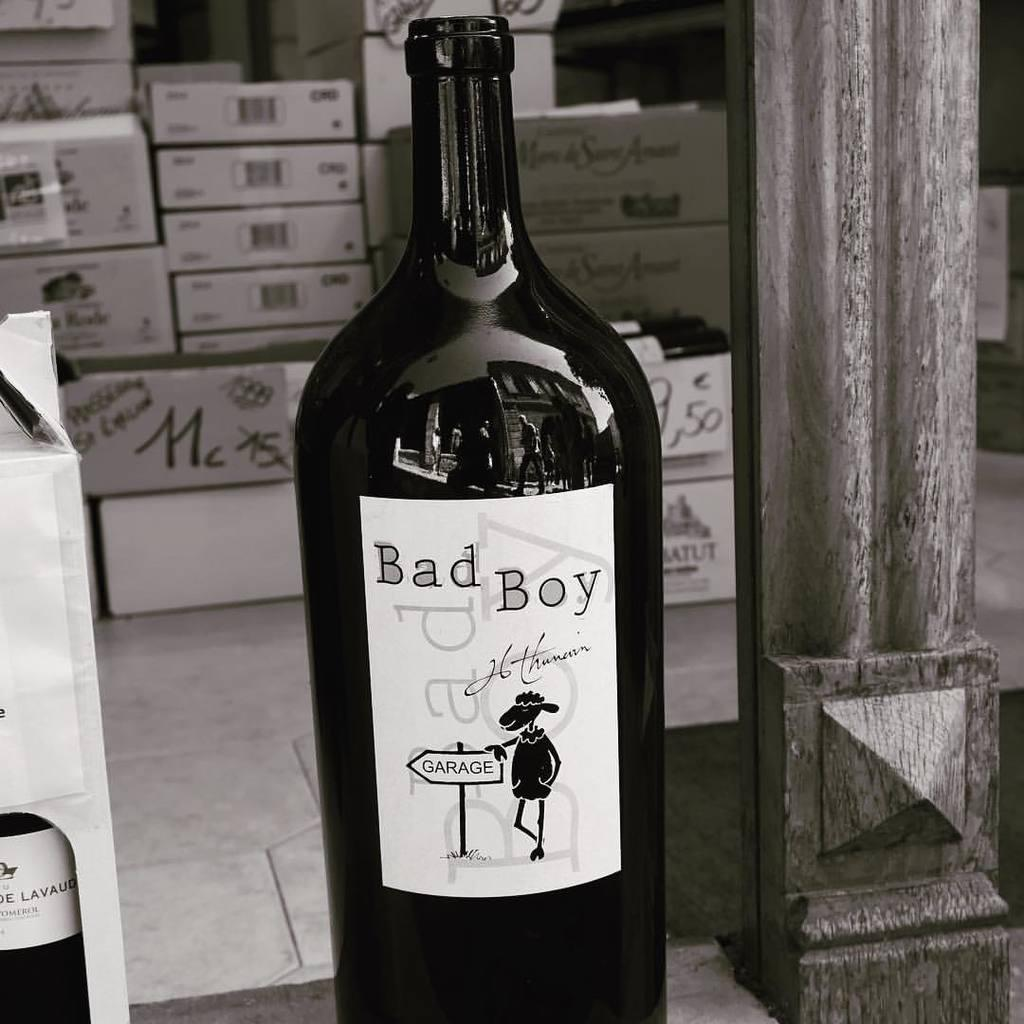<image>
Provide a brief description of the given image. A bottle that has the name Bad Boy on it. 